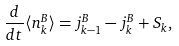Convert formula to latex. <formula><loc_0><loc_0><loc_500><loc_500>\frac { d } { d t } \langle n ^ { B } _ { k } \rangle = j ^ { B } _ { k - 1 } - j ^ { B } _ { k } + S _ { k } ,</formula> 